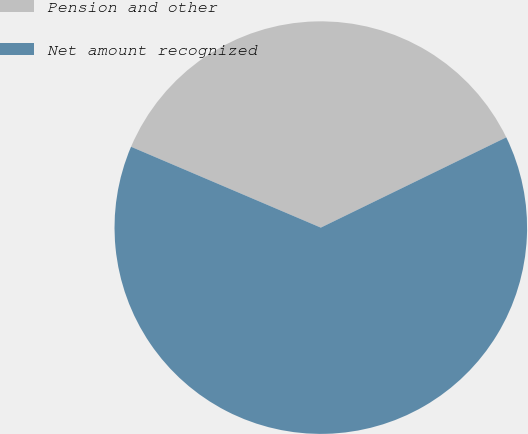Convert chart. <chart><loc_0><loc_0><loc_500><loc_500><pie_chart><fcel>Pension and other<fcel>Net amount recognized<nl><fcel>36.38%<fcel>63.62%<nl></chart> 